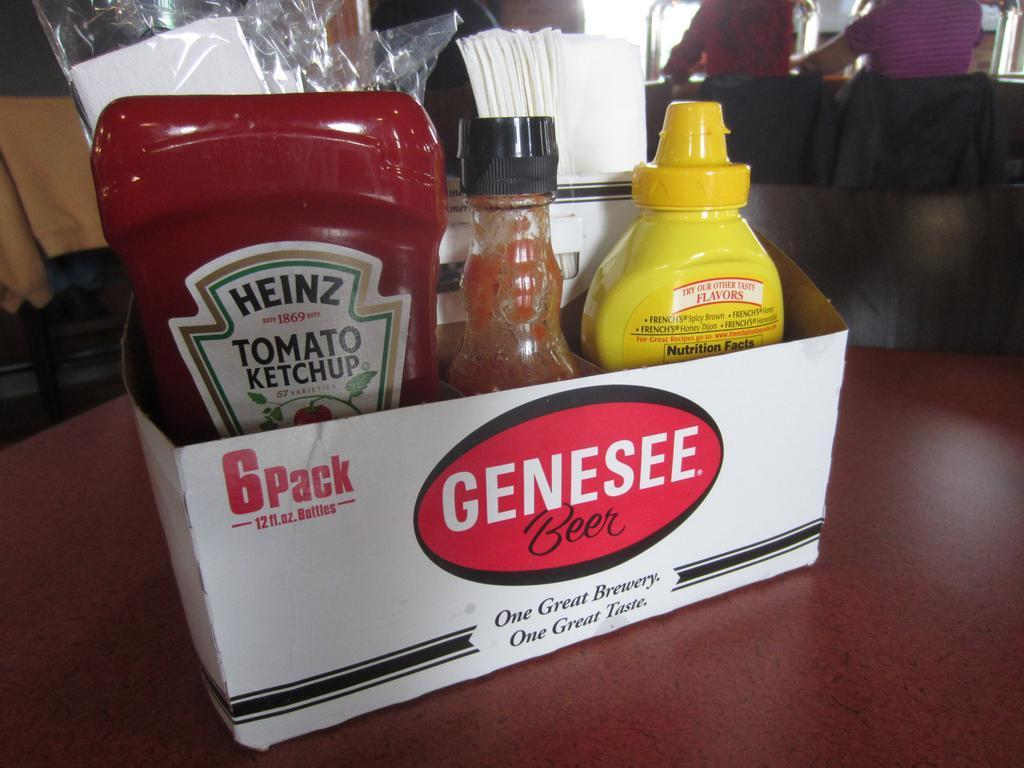Provide a one-sentence caption for the provided image. Some condiments including ketchup and mustard in a Genesee beer box. 